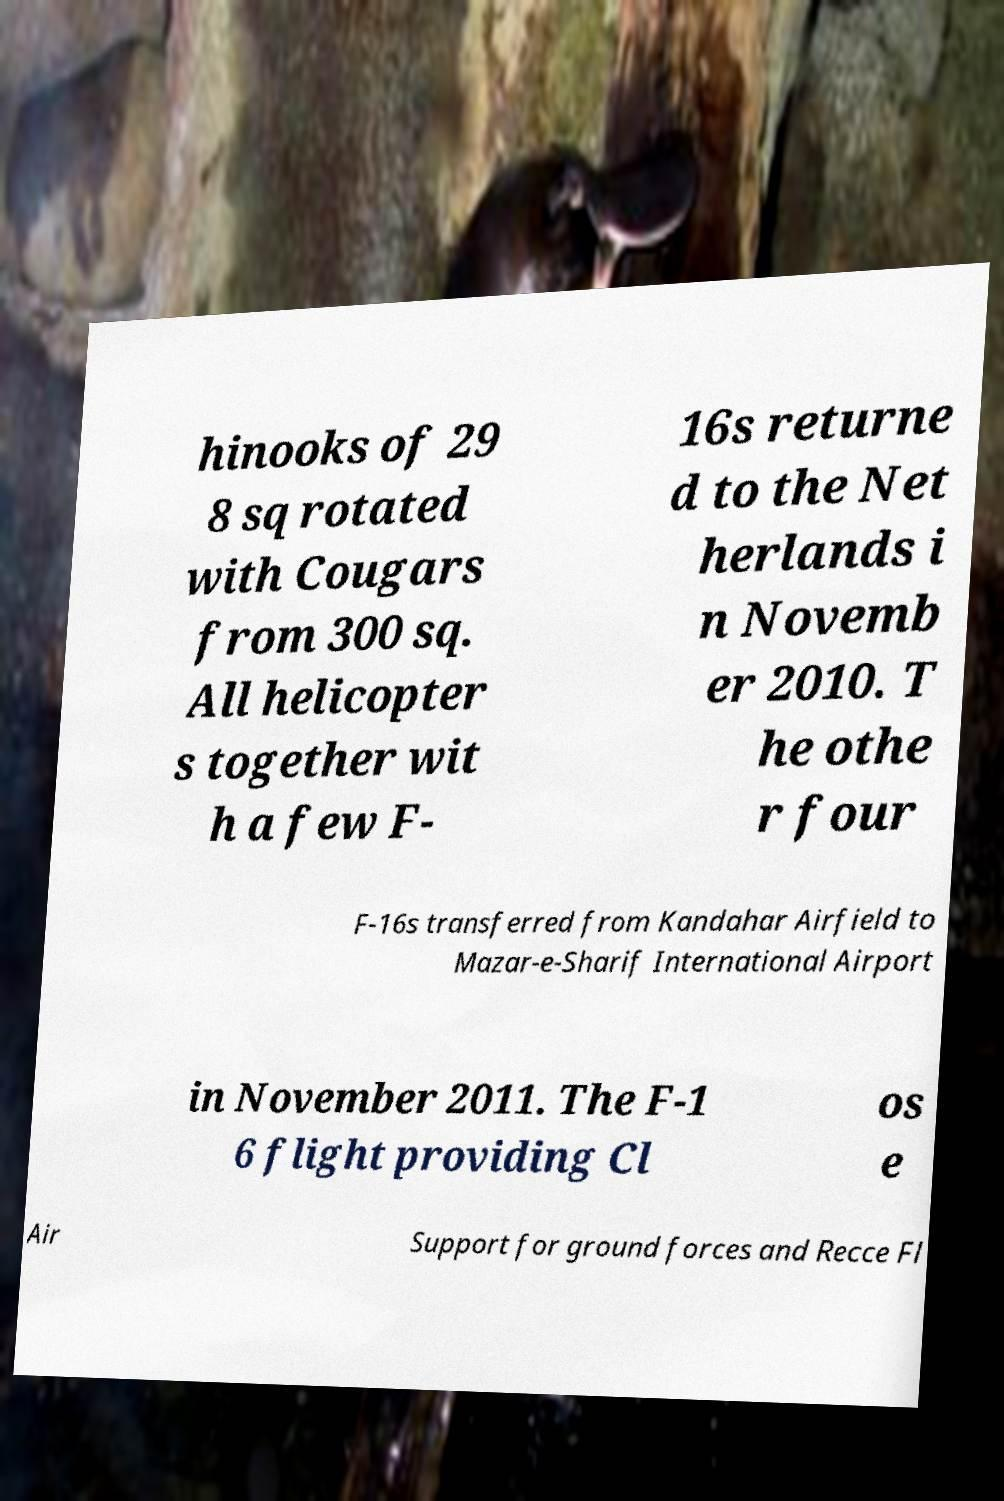What messages or text are displayed in this image? I need them in a readable, typed format. hinooks of 29 8 sq rotated with Cougars from 300 sq. All helicopter s together wit h a few F- 16s returne d to the Net herlands i n Novemb er 2010. T he othe r four F-16s transferred from Kandahar Airfield to Mazar-e-Sharif International Airport in November 2011. The F-1 6 flight providing Cl os e Air Support for ground forces and Recce Fl 